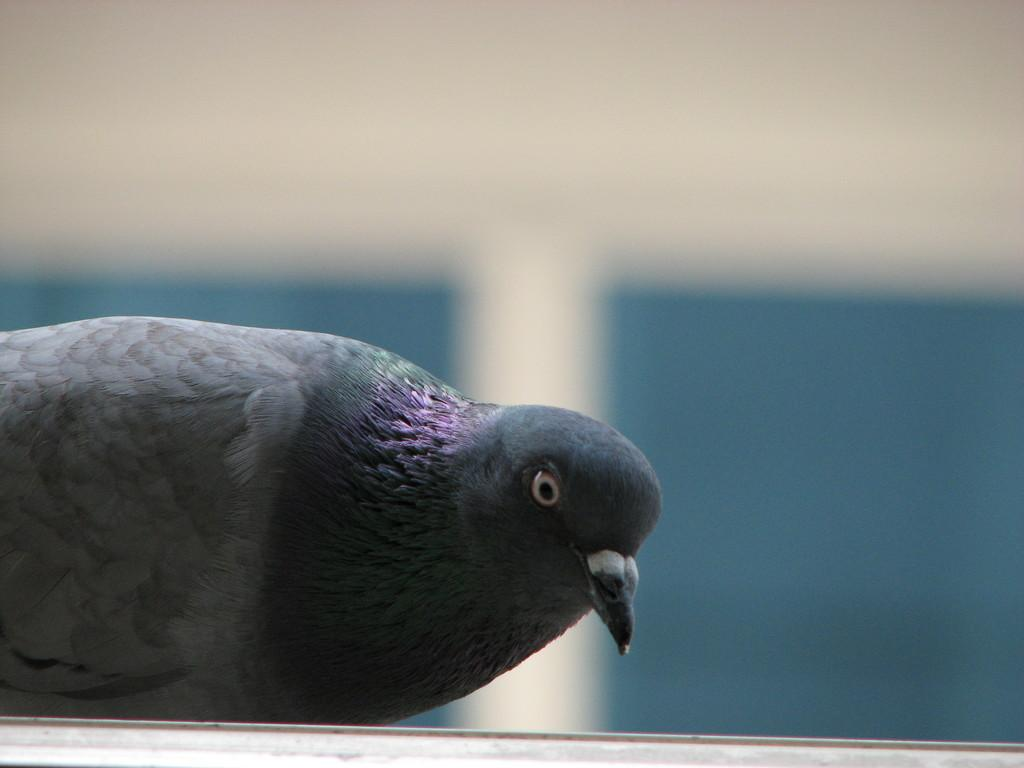What type of animal can be seen in the image? There is a bird in the image. Can you describe the background of the image? The background of the image is blurred. What discovery was made by the band in the image? There is no band present in the image, and therefore no discovery can be attributed to them. 